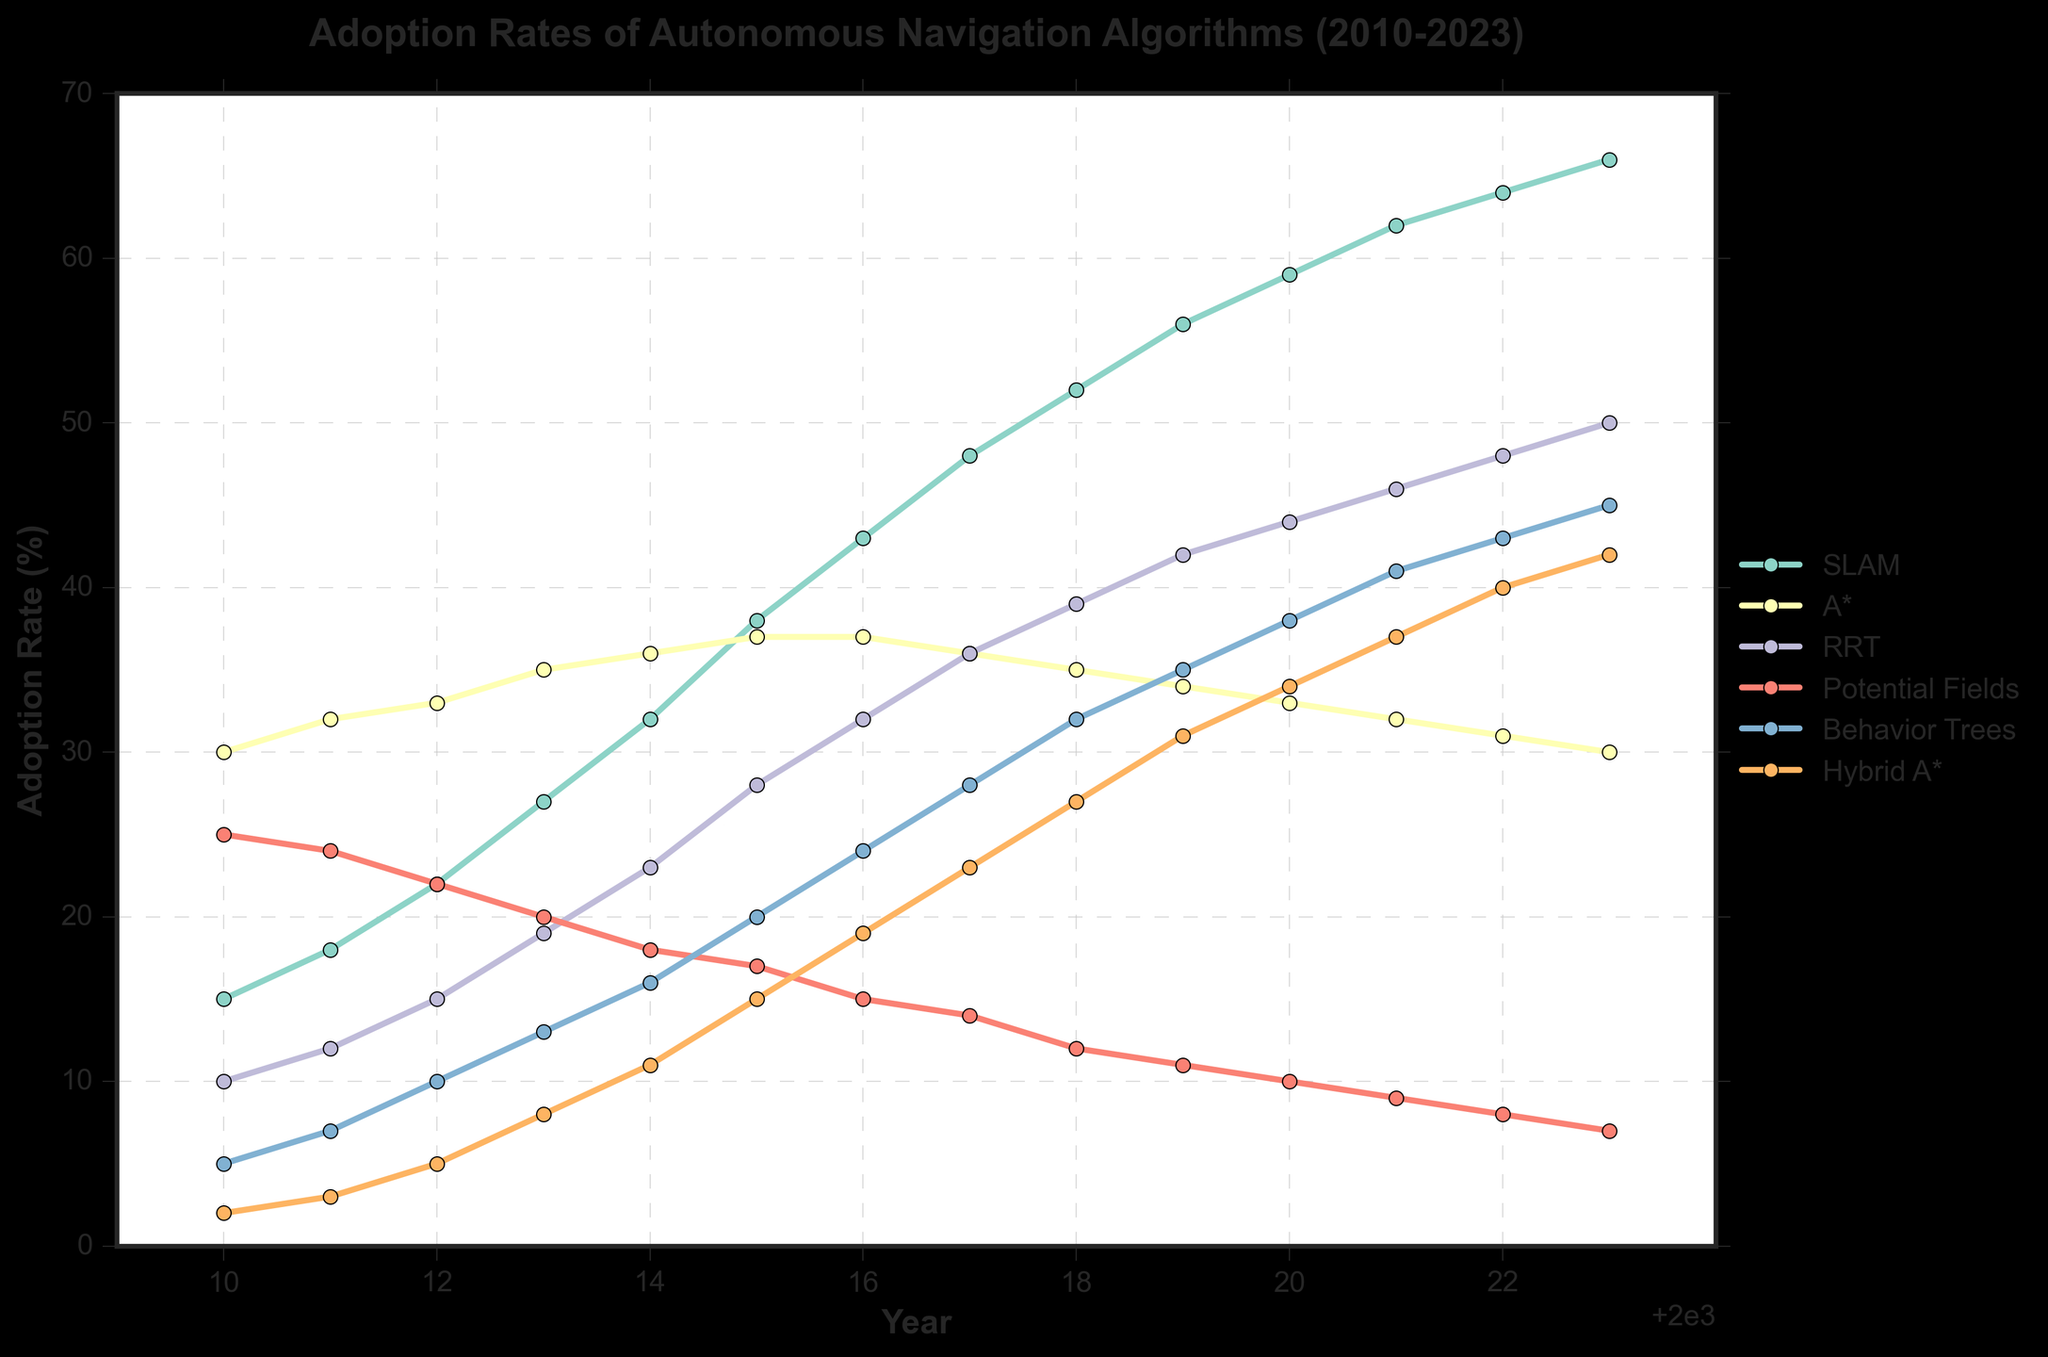what algorithm had the largest increase in adoption rate from 2010 to 2023? To find the algorithm with the largest increase in adoption rate, we need to subtract the 2010 value from the 2023 value for each algorithm. The increases are as follows: SLAM (66-15=51), A* (30-30=0), RRT (50-10=40), Potential Fields (7-25=-18), Behavior Trees (45-5=40), Hybrid A* (42-2=40). SLAM has the largest increase.
Answer: SLAM Which year did Hybrid A* surpass RRT in adoption rate? To find out when Hybrid A* surpassed RRT, we need to compare their adoption rates year by year. Hybrid A* surpasses RRT in 2018, when Hybrid A* reaches 27 and RRT is at 26.
Answer: 2018 What was the combined adoption rate of SLAM and Behavior Trees in 2023? To find the combined adoption rate of SLAM and Behavior Trees in 2023, we add the adoption rates of both for that year: SLAM (66) and Behavior Trees (45). The combined rate is 66 + 45 = 111.
Answer: 111 Which algorithm had a continuous decrease in adoption rate from 2010 to 2023? By observing the trend lines, we see that A* and Potential Fields have continuous decreases. A* drops from 30 to 30, and Potential Fields decreases from 25 to 7. Therefore, both had continuous drops.
Answer: A* and Potential Fields In which year did SLAM's adoption rate intersect with A*'s? To find the year the adoption rates of SLAM and A* intersect, observe the trend lines. They intersect in 2015 where SLAM is at 38 and A* is at 37.
Answer: 2015 Which algorithm had the most stable (least varying) adoption rate over the years? By observing the trend lines, A* remains mostly stable, starting at 30 in 2010 and ending around 30 in 2023, showing the least variation.
Answer: A* What is the average adoption rate of RRT from 2010 to 2023? To find the average, add RRT's adoption rates from 2010 to 2023 and divide by the number of years. The values are: 10, 12, 15, 19, 23, 28, 32, 36, 39, 42, 44, 46, 48, 50. Sum: 404. Average: 404 / 14 = 28.86
Answer: 28.86 What is the difference in adoption rate between Behavior Trees and Potential Fields in 2020? Looking at the year 2020, Behavior Trees have an adoption rate of 38, and Potential Fields have 10. The difference is 38 - 10 = 28.
Answer: 28 When did SLAM become the most adopted algorithm? SLAM becomes the most adopted algorithm in 2014, overtaking both A* and Potential Fields.
Answer: 2014 Compare the adoption rate trends between Behavior Trees and Hybrid A* from 2010 to 2023? Both Behavior Trees and Hybrid A* show steady increases in adoption rates. Behavior Trees start from 5 in 2010 and reach 45 in 2023, while Hybrid A* starts from 2 and reaches 42. Overall, their trends indicate rising popularity without any sharp declines.
Answer: Steady increases for both 